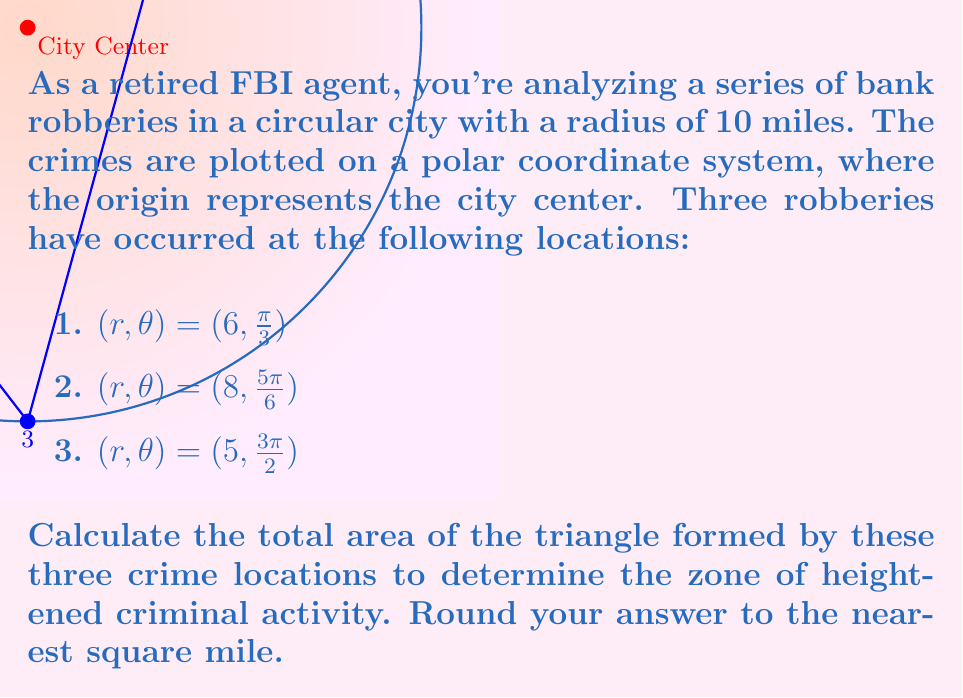Give your solution to this math problem. To solve this problem, we'll use the formula for the area of a triangle given three points in polar coordinates:

$$A = \frac{1}{2}|r_1r_2\sin(\theta_2 - \theta_1) + r_2r_3\sin(\theta_3 - \theta_2) + r_3r_1\sin(\theta_1 - \theta_3)|$$

Step 1: Identify the given points in polar coordinates:
Point 1: $(r_1, \theta_1) = (6, \frac{\pi}{3})$
Point 2: $(r_2, \theta_2) = (8, \frac{5\pi}{6})$
Point 3: $(r_3, \theta_3) = (5, \frac{3\pi}{2})$

Step 2: Calculate the differences between the angles:
$\theta_2 - \theta_1 = \frac{5\pi}{6} - \frac{\pi}{3} = \frac{\pi}{2}$
$\theta_3 - \theta_2 = \frac{3\pi}{2} - \frac{5\pi}{6} = \frac{2\pi}{3}$
$\theta_1 - \theta_3 = \frac{\pi}{3} - \frac{3\pi}{2} = -\frac{7\pi}{6}$

Step 3: Apply the formula:

$$\begin{align*}
A &= \frac{1}{2}|6 \cdot 8 \cdot \sin(\frac{\pi}{2}) + 8 \cdot 5 \cdot \sin(\frac{2\pi}{3}) + 5 \cdot 6 \cdot \sin(-\frac{7\pi}{6})|\\
&= \frac{1}{2}|6 \cdot 8 \cdot 1 + 8 \cdot 5 \cdot \frac{\sqrt{3}}{2} + 5 \cdot 6 \cdot (-\frac{\sqrt{3}}{2})|\\
&= \frac{1}{2}|48 + 20\sqrt{3} - 15\sqrt{3}|\\
&= \frac{1}{2}|48 + 5\sqrt{3}|\\
&= 24 + \frac{5\sqrt{3}}{2}\\
&\approx 28.33
\end{align*}$$

Step 4: Round to the nearest square mile:
28.33 rounded to the nearest whole number is 28.
Answer: 28 square miles 